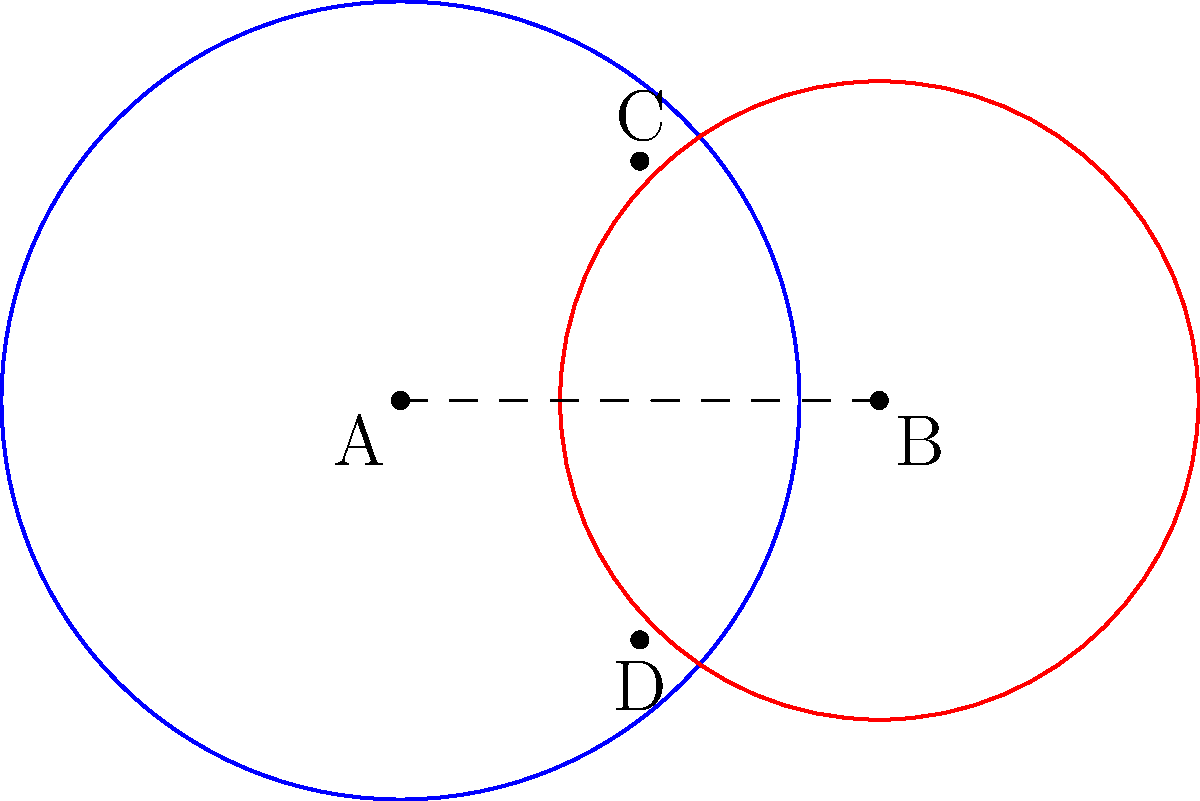Two healthcare coverage areas are represented by intersecting circles with centers A and B. Circle A has a radius of 5 units, and circle B has a radius of 4 units. The distance between their centers is 6 units. Calculate the area of the region where the two coverage areas overlap, representing the population with access to both healthcare systems. Round your answer to two decimal places. Let's approach this step-by-step:

1) First, we need to find the distance from the center of each circle to the line of intersection. Let's call this distance $x$ for circle A and $y$ for circle B.

2) Using the Pythagorean theorem:
   $5^2 = x^2 + 3^2$ and $4^2 = y^2 + 3^2$

3) Solving these equations:
   $x = \sqrt{5^2 - 3^2} = 4$ and $y = \sqrt{4^2 - 3^2} = \sqrt{7}$

4) The area of the overlapping region can be calculated by subtracting the areas of two segments from the sum of the areas of the two circles:

   Area = $\pi r_1^2 + \pi r_2^2 - (A_1 + A_2)$

   Where $A_1$ and $A_2$ are the areas of the segments.

5) The area of a segment is given by:
   $A = r^2 \arccos(\frac{r-h}{r}) - (r-h)\sqrt{2rh-h^2}$

   Where $h$ is the height of the segment, which in our case is $r - x$ for circle A and $r - y$ for circle B.

6) For circle A:
   $h_1 = 5 - 4 = 1$
   $A_1 = 5^2 \arccos(\frac{4}{5}) - 4\sqrt{10-1} = 25 \arccos(0.8) - 4\sqrt{9}$

7) For circle B:
   $h_2 = 4 - \sqrt{7} = 4 - 2.6458 = 1.3542$
   $A_2 = 4^2 \arccos(\frac{\sqrt{7}}{4}) - \sqrt{7}\sqrt{8-7} = 16 \arccos(0.6614) - \sqrt{7}$

8) Now, we can calculate the overlapping area:
   Area = $\pi 5^2 + \pi 4^2 - (25 \arccos(0.8) - 12 + 16 \arccos(0.6614) - \sqrt{7})$

9) Calculating this gives us approximately 16.40 square units.
Answer: 16.40 square units 